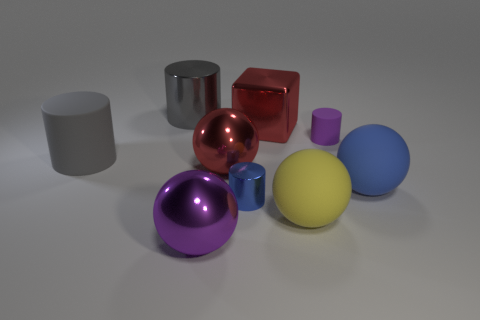Subtract all big shiny cylinders. How many cylinders are left? 3 Subtract all blue cylinders. How many cylinders are left? 3 Subtract all spheres. How many objects are left? 5 Subtract all yellow balls. Subtract all green cylinders. How many balls are left? 3 Subtract all brown cylinders. How many green cubes are left? 0 Subtract all matte balls. Subtract all large cylinders. How many objects are left? 5 Add 6 big yellow objects. How many big yellow objects are left? 7 Add 5 red spheres. How many red spheres exist? 6 Subtract 0 green balls. How many objects are left? 9 Subtract 2 cylinders. How many cylinders are left? 2 